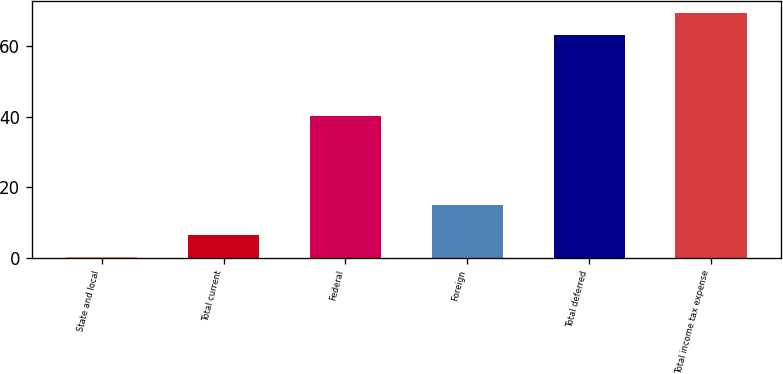Convert chart. <chart><loc_0><loc_0><loc_500><loc_500><bar_chart><fcel>State and local<fcel>Total current<fcel>Federal<fcel>Foreign<fcel>Total deferred<fcel>Total income tax expense<nl><fcel>0.2<fcel>6.56<fcel>40.3<fcel>15<fcel>63.1<fcel>69.46<nl></chart> 